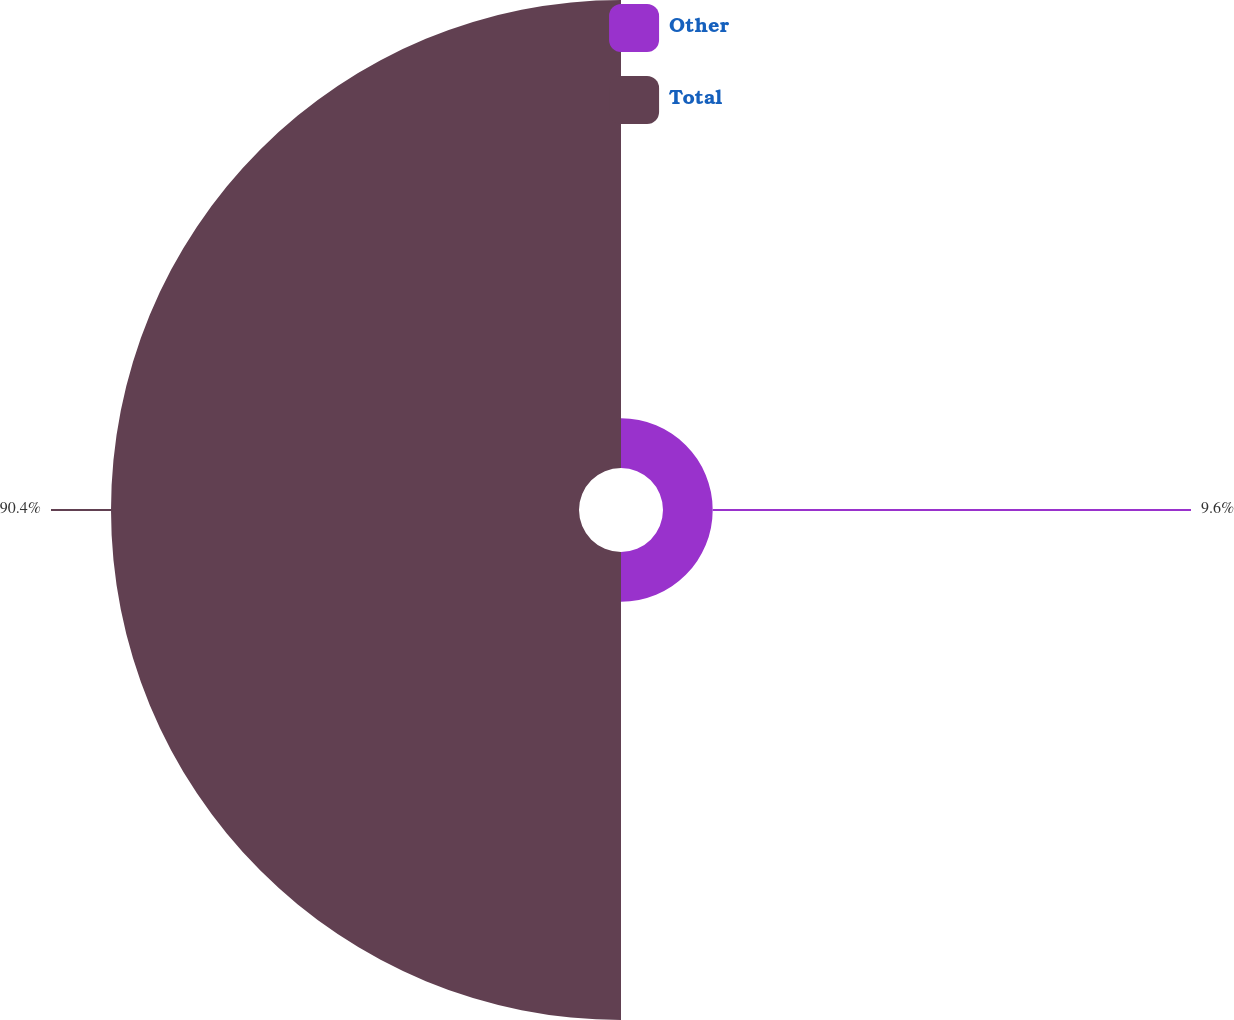<chart> <loc_0><loc_0><loc_500><loc_500><pie_chart><fcel>Other<fcel>Total<nl><fcel>9.6%<fcel>90.4%<nl></chart> 